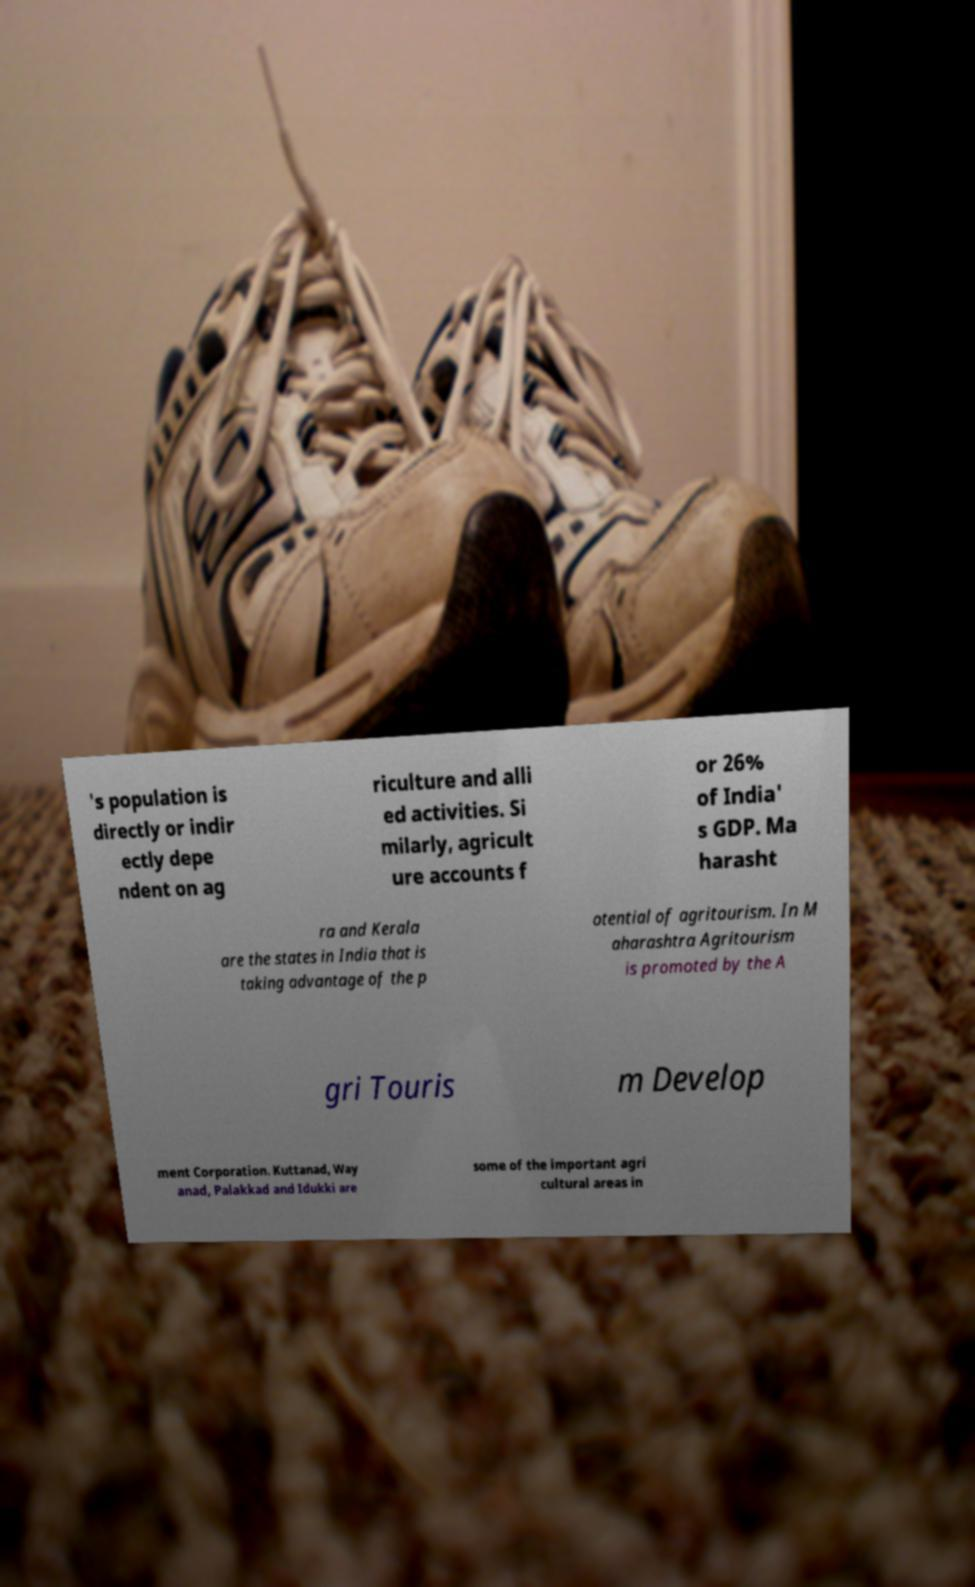Could you extract and type out the text from this image? 's population is directly or indir ectly depe ndent on ag riculture and alli ed activities. Si milarly, agricult ure accounts f or 26% of India' s GDP. Ma harasht ra and Kerala are the states in India that is taking advantage of the p otential of agritourism. In M aharashtra Agritourism is promoted by the A gri Touris m Develop ment Corporation. Kuttanad, Way anad, Palakkad and Idukki are some of the important agri cultural areas in 